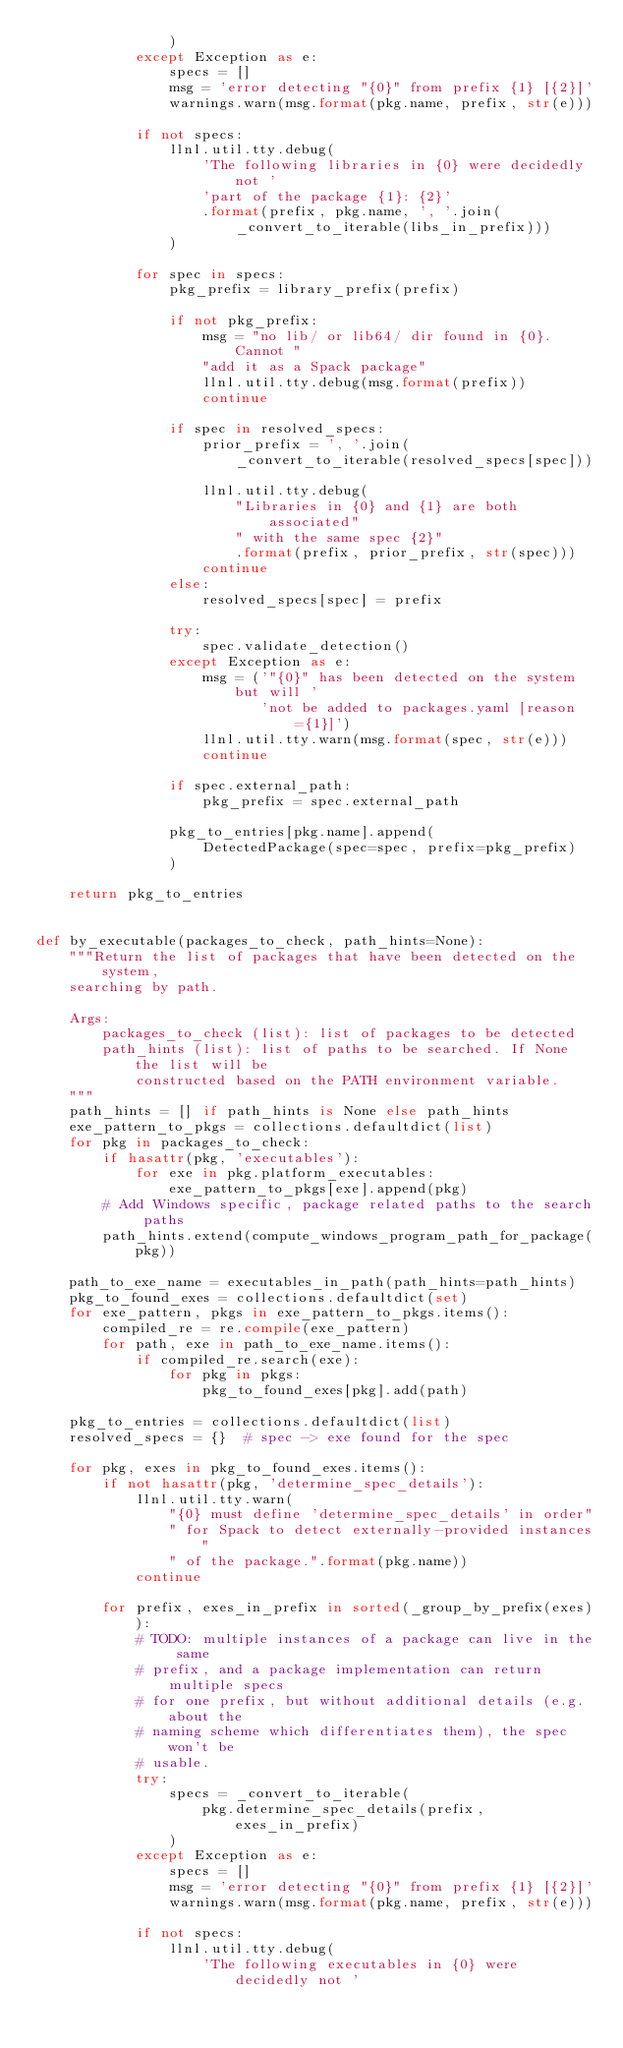<code> <loc_0><loc_0><loc_500><loc_500><_Python_>                )
            except Exception as e:
                specs = []
                msg = 'error detecting "{0}" from prefix {1} [{2}]'
                warnings.warn(msg.format(pkg.name, prefix, str(e)))

            if not specs:
                llnl.util.tty.debug(
                    'The following libraries in {0} were decidedly not '
                    'part of the package {1}: {2}'
                    .format(prefix, pkg.name, ', '.join(
                        _convert_to_iterable(libs_in_prefix)))
                )

            for spec in specs:
                pkg_prefix = library_prefix(prefix)

                if not pkg_prefix:
                    msg = "no lib/ or lib64/ dir found in {0}. Cannot "
                    "add it as a Spack package"
                    llnl.util.tty.debug(msg.format(prefix))
                    continue

                if spec in resolved_specs:
                    prior_prefix = ', '.join(
                        _convert_to_iterable(resolved_specs[spec]))

                    llnl.util.tty.debug(
                        "Libraries in {0} and {1} are both associated"
                        " with the same spec {2}"
                        .format(prefix, prior_prefix, str(spec)))
                    continue
                else:
                    resolved_specs[spec] = prefix

                try:
                    spec.validate_detection()
                except Exception as e:
                    msg = ('"{0}" has been detected on the system but will '
                           'not be added to packages.yaml [reason={1}]')
                    llnl.util.tty.warn(msg.format(spec, str(e)))
                    continue

                if spec.external_path:
                    pkg_prefix = spec.external_path

                pkg_to_entries[pkg.name].append(
                    DetectedPackage(spec=spec, prefix=pkg_prefix)
                )

    return pkg_to_entries


def by_executable(packages_to_check, path_hints=None):
    """Return the list of packages that have been detected on the system,
    searching by path.

    Args:
        packages_to_check (list): list of packages to be detected
        path_hints (list): list of paths to be searched. If None the list will be
            constructed based on the PATH environment variable.
    """
    path_hints = [] if path_hints is None else path_hints
    exe_pattern_to_pkgs = collections.defaultdict(list)
    for pkg in packages_to_check:
        if hasattr(pkg, 'executables'):
            for exe in pkg.platform_executables:
                exe_pattern_to_pkgs[exe].append(pkg)
        # Add Windows specific, package related paths to the search paths
        path_hints.extend(compute_windows_program_path_for_package(pkg))

    path_to_exe_name = executables_in_path(path_hints=path_hints)
    pkg_to_found_exes = collections.defaultdict(set)
    for exe_pattern, pkgs in exe_pattern_to_pkgs.items():
        compiled_re = re.compile(exe_pattern)
        for path, exe in path_to_exe_name.items():
            if compiled_re.search(exe):
                for pkg in pkgs:
                    pkg_to_found_exes[pkg].add(path)

    pkg_to_entries = collections.defaultdict(list)
    resolved_specs = {}  # spec -> exe found for the spec

    for pkg, exes in pkg_to_found_exes.items():
        if not hasattr(pkg, 'determine_spec_details'):
            llnl.util.tty.warn(
                "{0} must define 'determine_spec_details' in order"
                " for Spack to detect externally-provided instances"
                " of the package.".format(pkg.name))
            continue

        for prefix, exes_in_prefix in sorted(_group_by_prefix(exes)):
            # TODO: multiple instances of a package can live in the same
            # prefix, and a package implementation can return multiple specs
            # for one prefix, but without additional details (e.g. about the
            # naming scheme which differentiates them), the spec won't be
            # usable.
            try:
                specs = _convert_to_iterable(
                    pkg.determine_spec_details(prefix, exes_in_prefix)
                )
            except Exception as e:
                specs = []
                msg = 'error detecting "{0}" from prefix {1} [{2}]'
                warnings.warn(msg.format(pkg.name, prefix, str(e)))

            if not specs:
                llnl.util.tty.debug(
                    'The following executables in {0} were decidedly not '</code> 